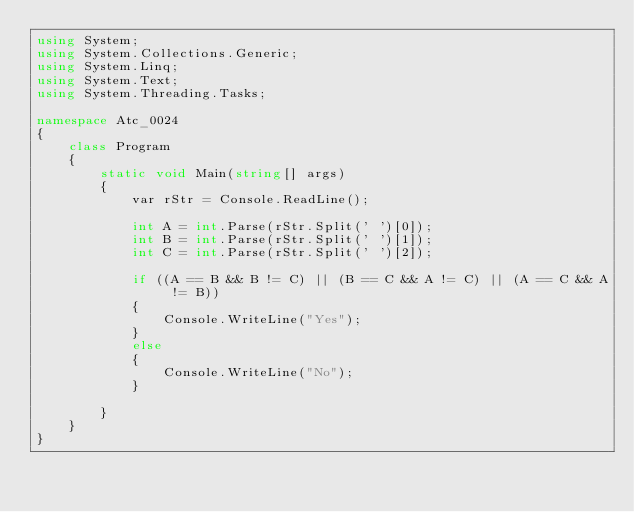Convert code to text. <code><loc_0><loc_0><loc_500><loc_500><_C#_>using System;
using System.Collections.Generic;
using System.Linq;
using System.Text;
using System.Threading.Tasks;

namespace Atc_0024
{
    class Program
    {
        static void Main(string[] args)
        {
            var rStr = Console.ReadLine();

            int A = int.Parse(rStr.Split(' ')[0]);
            int B = int.Parse(rStr.Split(' ')[1]);
            int C = int.Parse(rStr.Split(' ')[2]);

            if ((A == B && B != C) || (B == C && A != C) || (A == C && A != B))
            {
                Console.WriteLine("Yes");
            }
            else
            {
                Console.WriteLine("No");
            }

        }
    }
}
</code> 